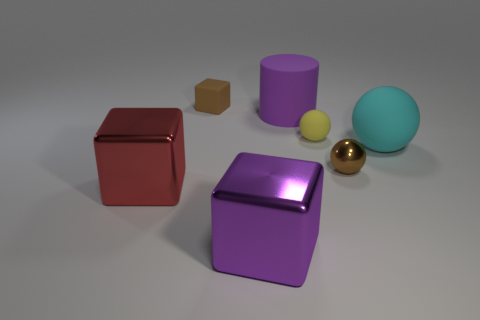There is a tiny brown object behind the large matte sphere; is its shape the same as the large rubber object right of the large rubber cylinder?
Offer a terse response. No. Are there any large purple objects in front of the yellow thing?
Keep it short and to the point. Yes. There is another big shiny thing that is the same shape as the purple shiny thing; what is its color?
Ensure brevity in your answer.  Red. Are there any other things that have the same shape as the purple rubber object?
Offer a terse response. No. There is a yellow ball that is in front of the tiny block; what is its material?
Keep it short and to the point. Rubber. What is the size of the yellow matte thing that is the same shape as the cyan object?
Make the answer very short. Small. What number of red blocks are the same material as the tiny brown cube?
Your answer should be very brief. 0. What number of tiny things have the same color as the small matte cube?
Ensure brevity in your answer.  1. How many things are either small matte objects that are in front of the rubber cube or metallic objects on the right side of the small matte cube?
Keep it short and to the point. 3. Is the number of red things that are behind the large red metallic object less than the number of large purple matte cylinders?
Offer a terse response. Yes. 